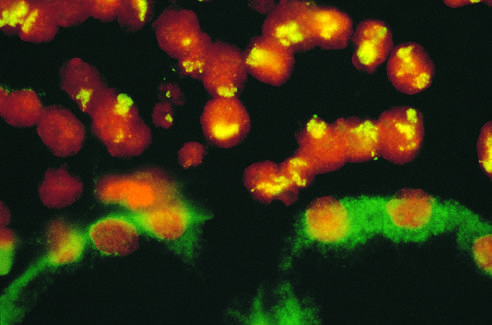what is attached to the kidney?
Answer the question using a single word or phrase. Neuroblastoma 